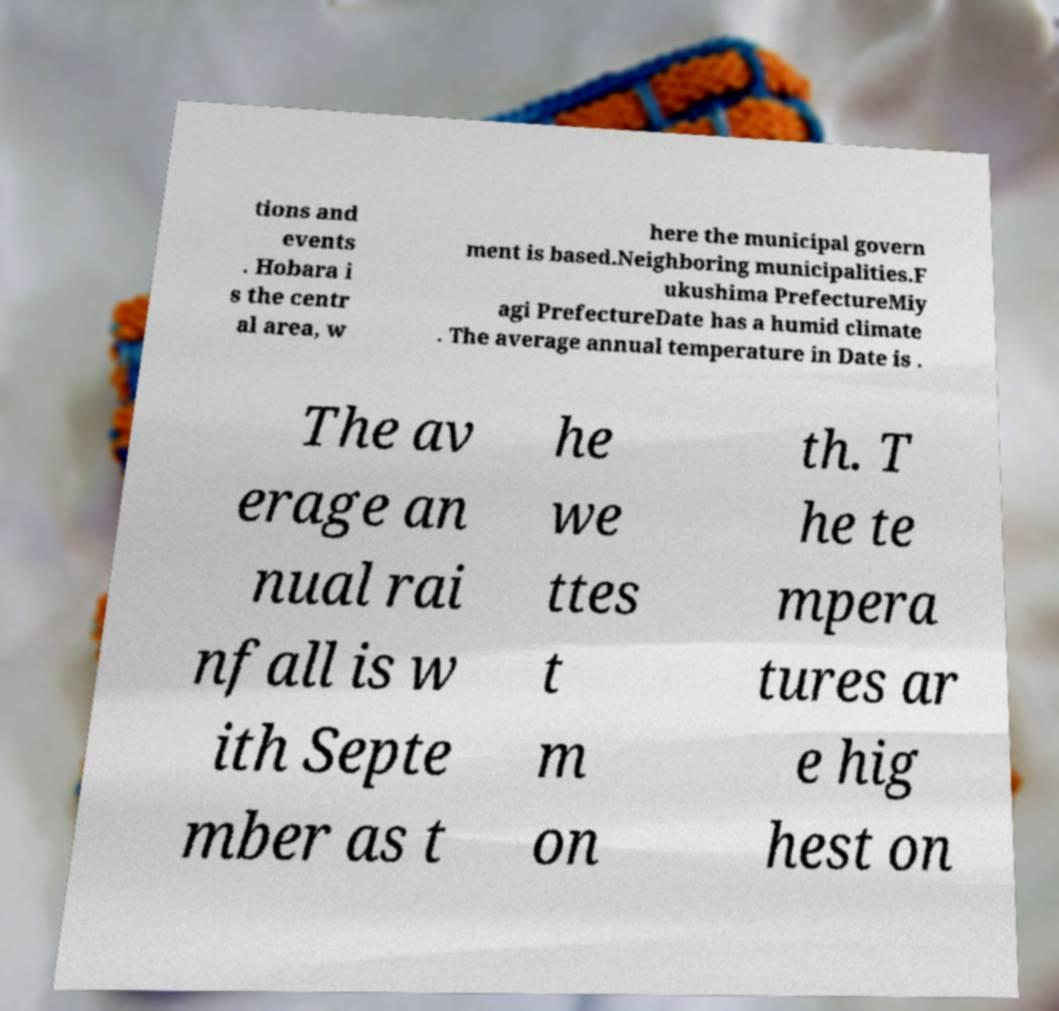What messages or text are displayed in this image? I need them in a readable, typed format. tions and events . Hobara i s the centr al area, w here the municipal govern ment is based.Neighboring municipalities.F ukushima PrefectureMiy agi PrefectureDate has a humid climate . The average annual temperature in Date is . The av erage an nual rai nfall is w ith Septe mber as t he we ttes t m on th. T he te mpera tures ar e hig hest on 